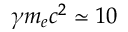<formula> <loc_0><loc_0><loc_500><loc_500>\gamma m _ { e } c ^ { 2 } \simeq 1 0</formula> 